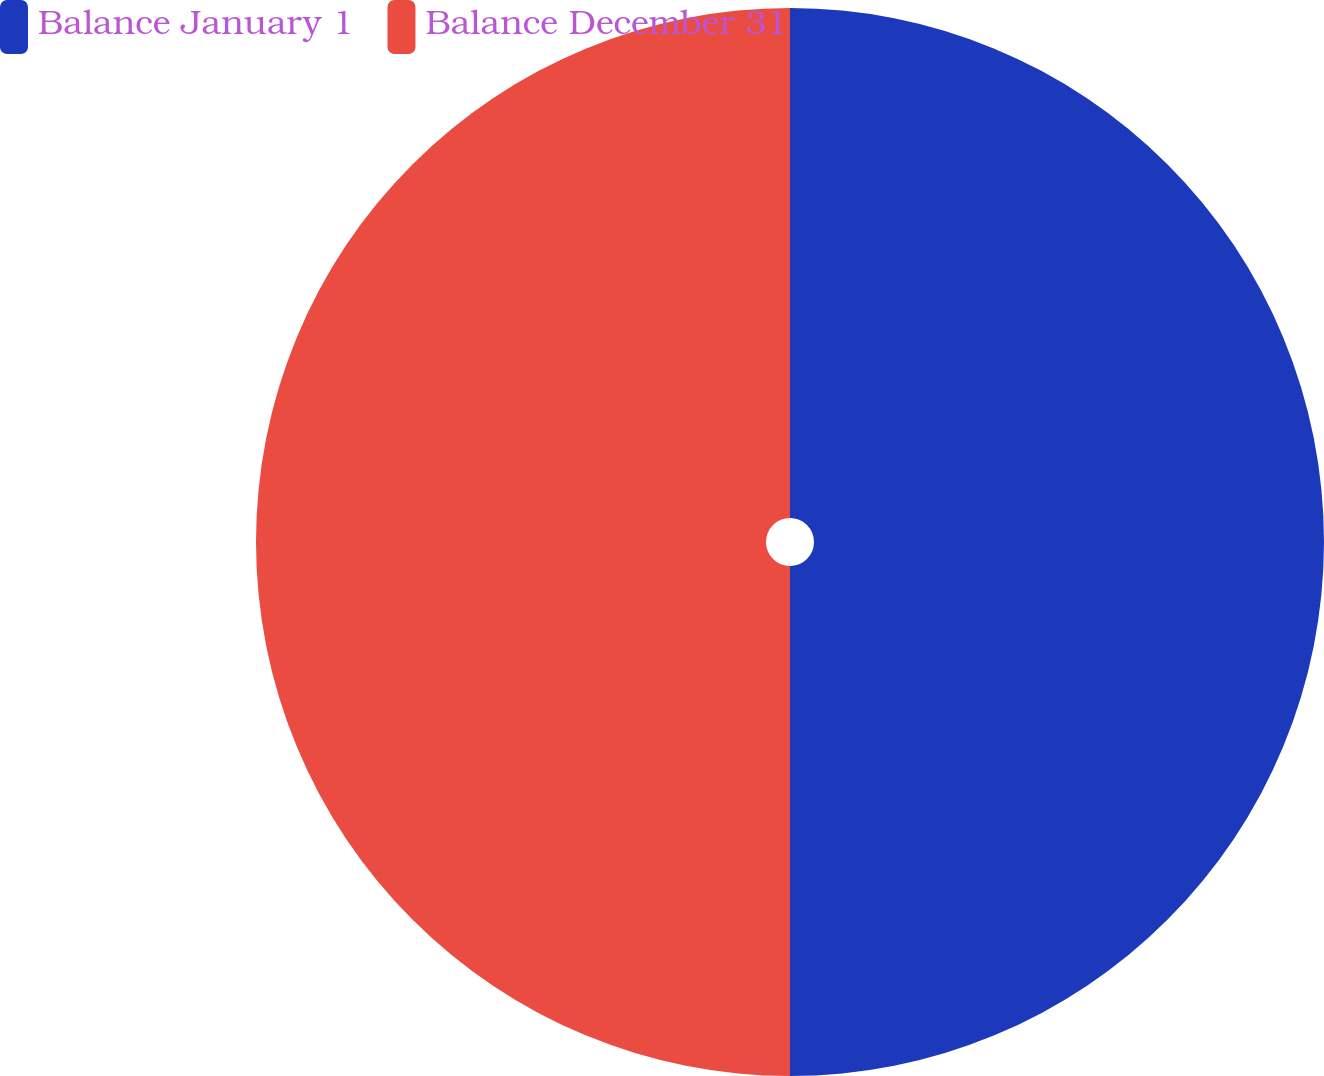<chart> <loc_0><loc_0><loc_500><loc_500><pie_chart><fcel>Balance January 1<fcel>Balance December 31<nl><fcel>50.0%<fcel>50.0%<nl></chart> 